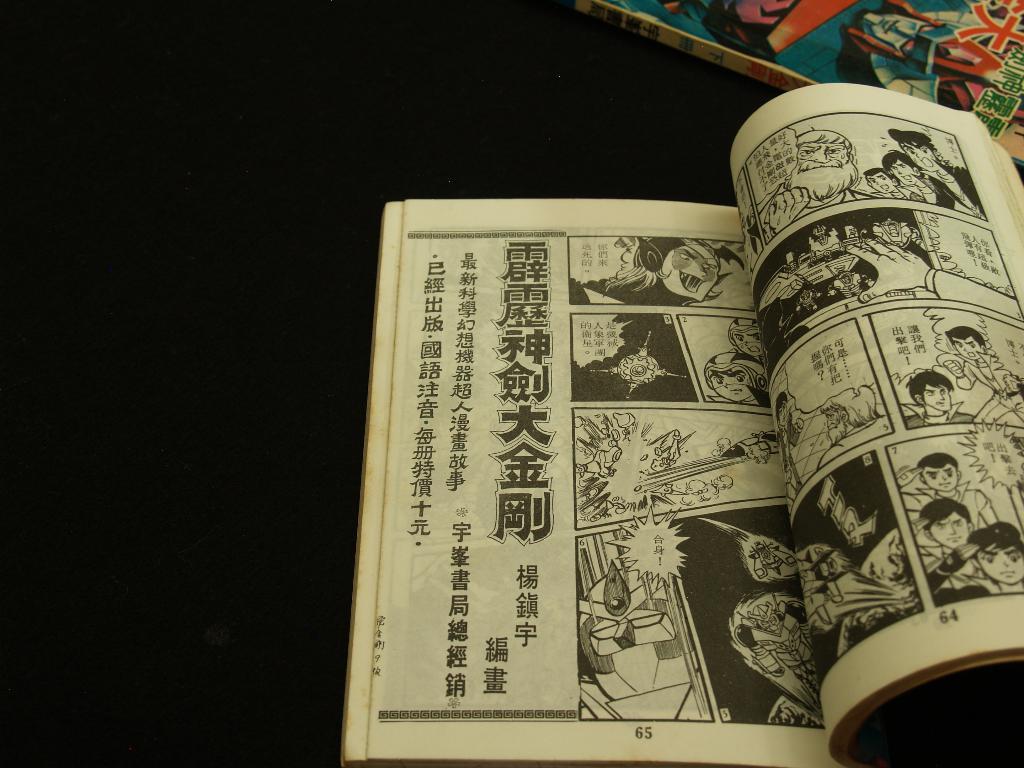Is this comic drawn by an asian artist?
Your answer should be very brief. Yes. 